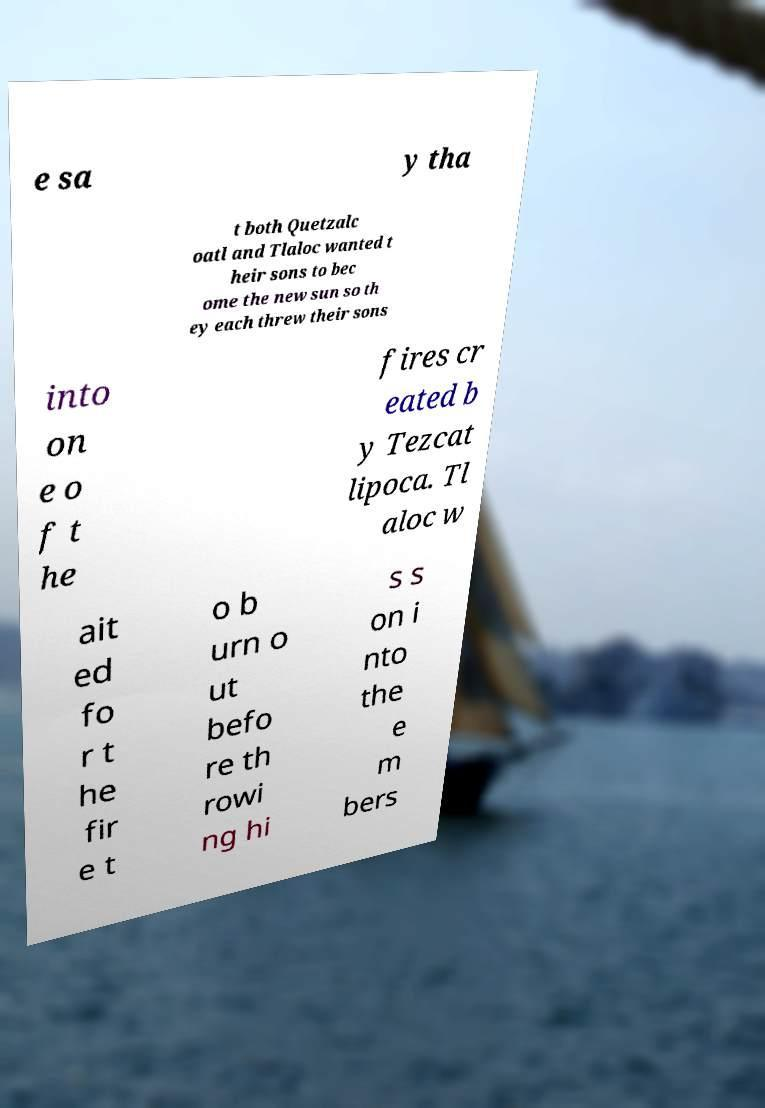What messages or text are displayed in this image? I need them in a readable, typed format. e sa y tha t both Quetzalc oatl and Tlaloc wanted t heir sons to bec ome the new sun so th ey each threw their sons into on e o f t he fires cr eated b y Tezcat lipoca. Tl aloc w ait ed fo r t he fir e t o b urn o ut befo re th rowi ng hi s s on i nto the e m bers 